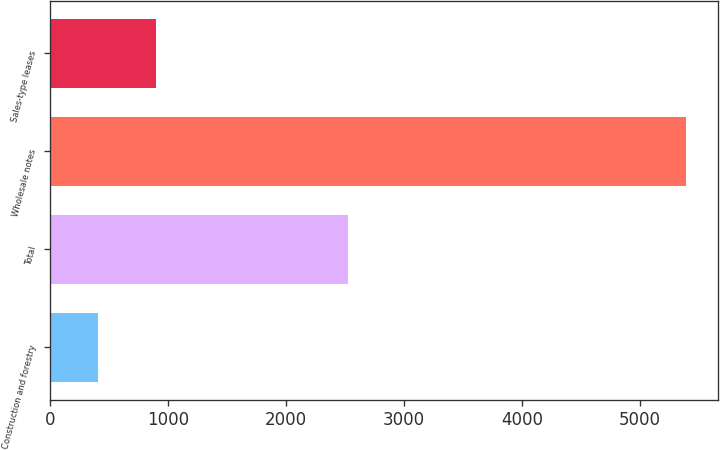Convert chart to OTSL. <chart><loc_0><loc_0><loc_500><loc_500><bar_chart><fcel>Construction and forestry<fcel>Total<fcel>Wholesale notes<fcel>Sales-type leases<nl><fcel>403<fcel>2528<fcel>5390<fcel>901.7<nl></chart> 